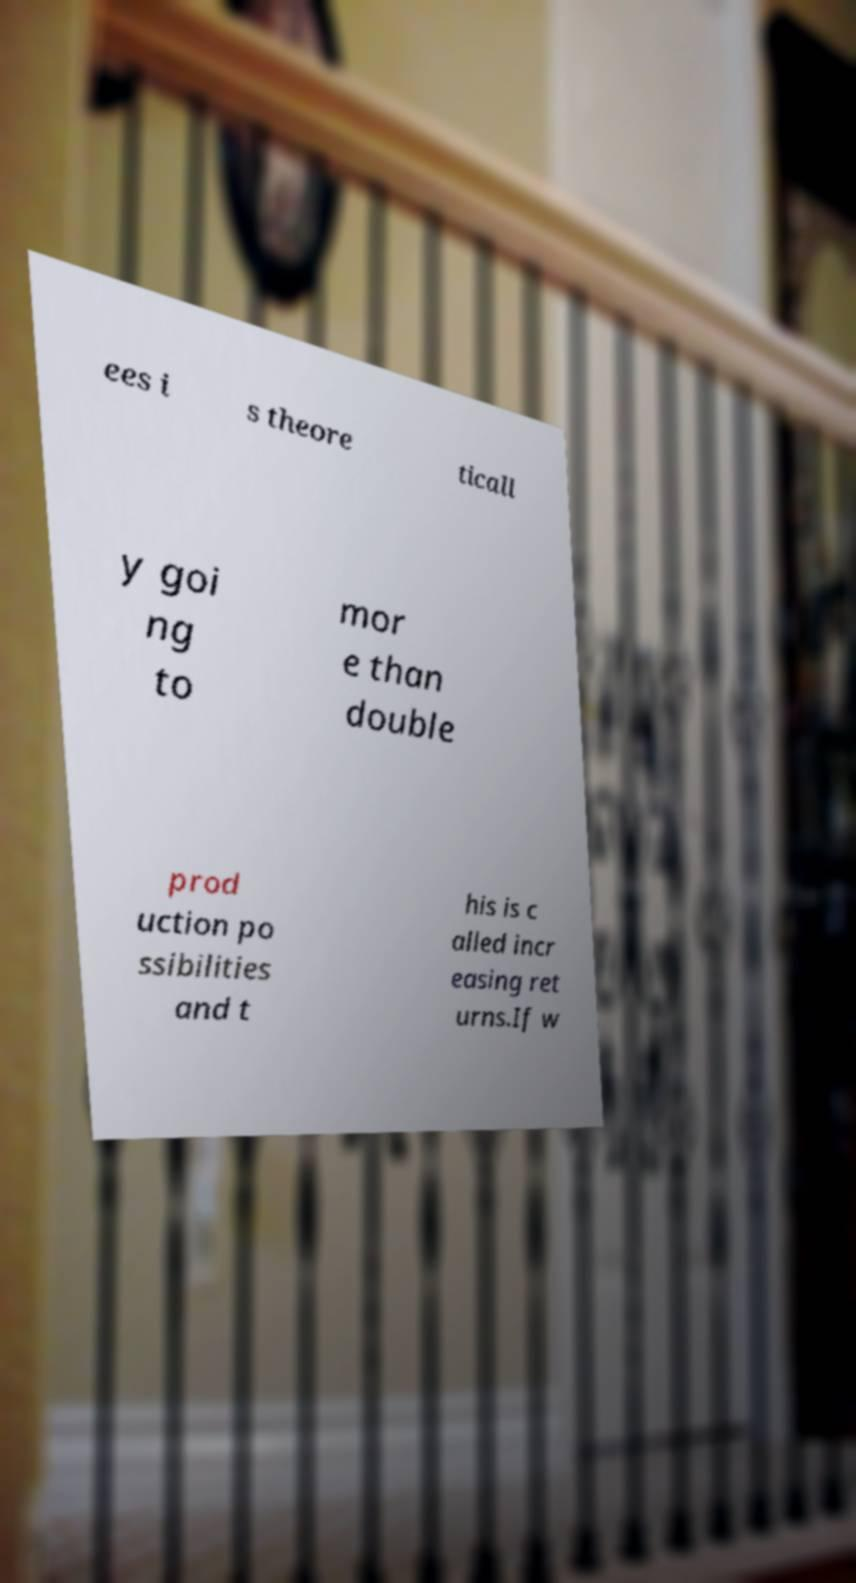Could you assist in decoding the text presented in this image and type it out clearly? ees i s theore ticall y goi ng to mor e than double prod uction po ssibilities and t his is c alled incr easing ret urns.If w 